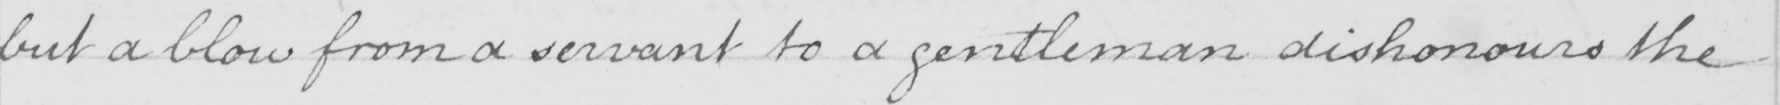Can you read and transcribe this handwriting? but a blow from a servant to a gentleman dishonours the 